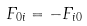Convert formula to latex. <formula><loc_0><loc_0><loc_500><loc_500>F _ { 0 i } = - F _ { i 0 }</formula> 